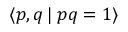Convert formula to latex. <formula><loc_0><loc_0><loc_500><loc_500>\langle p , q \, | \, p q = 1 \rangle</formula> 